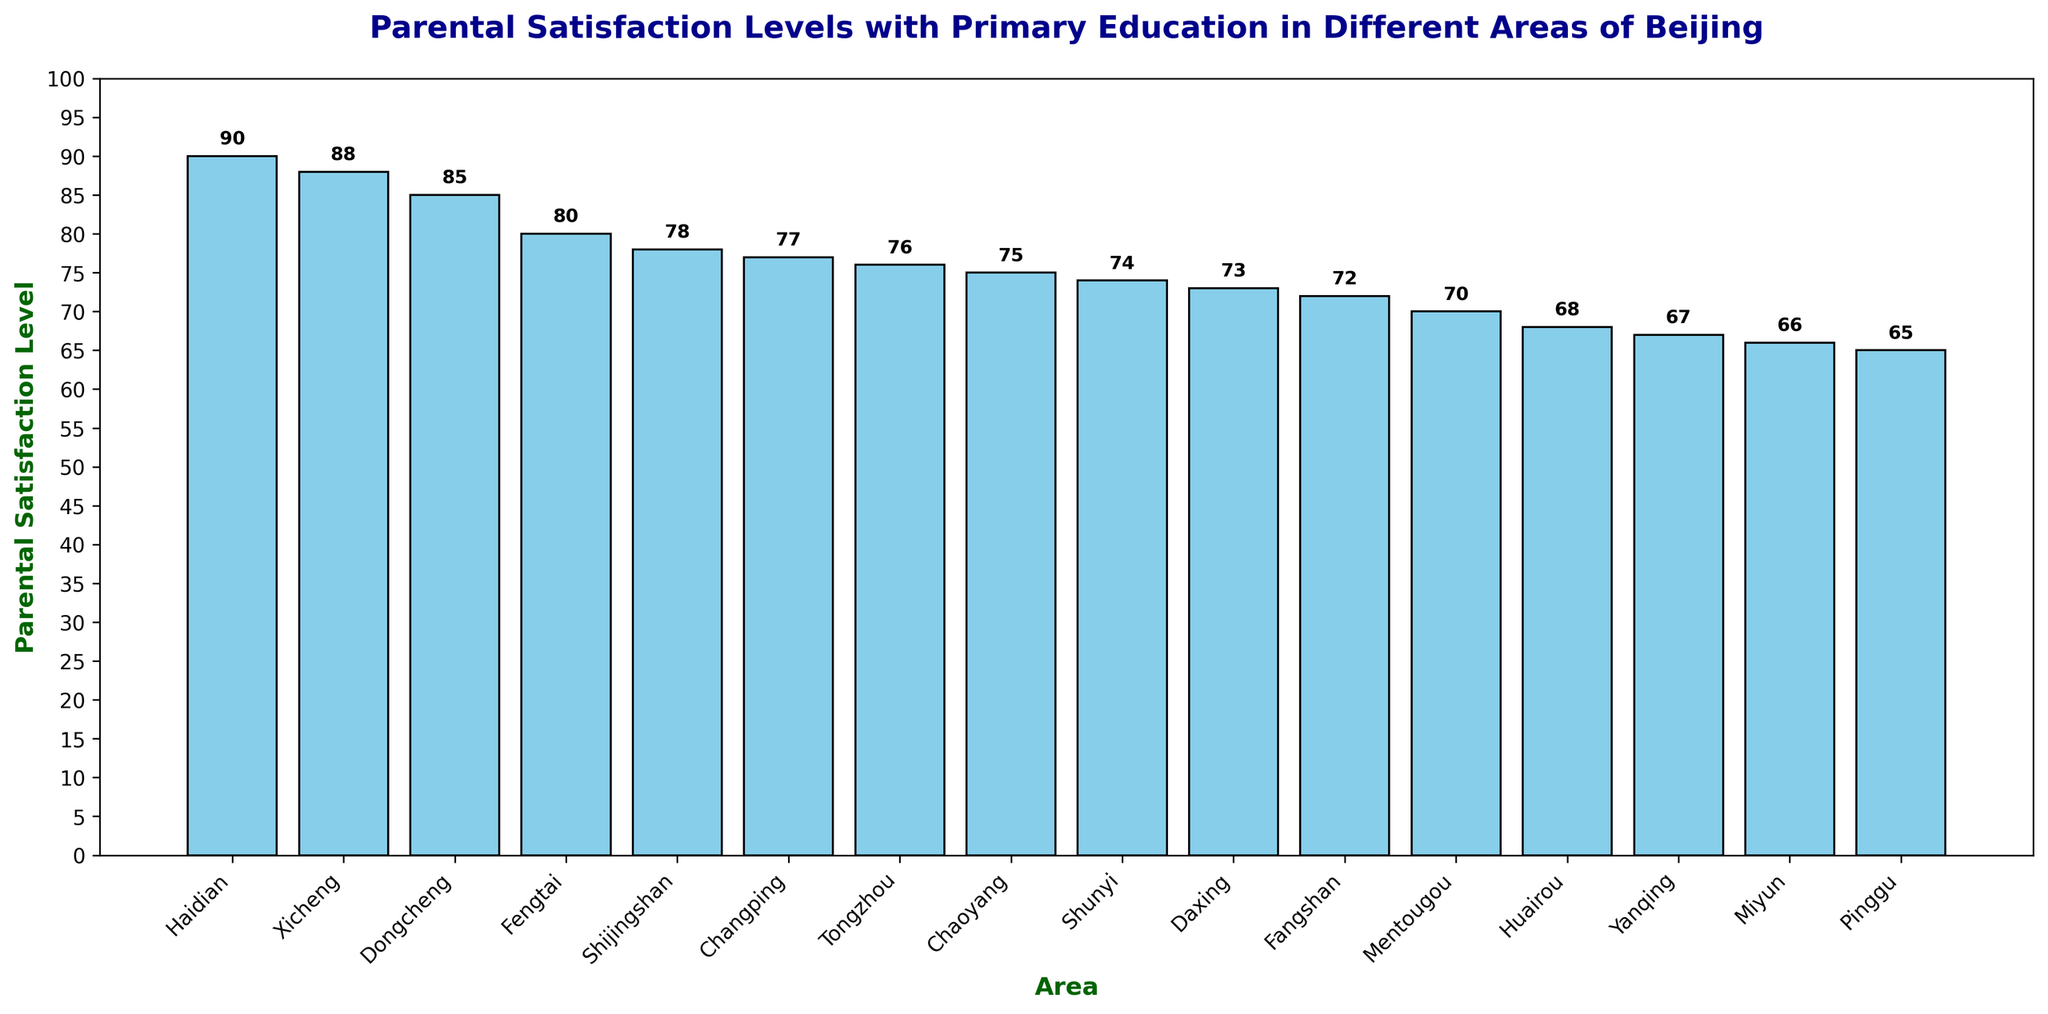What's the parental satisfaction level in Fengtai? Fengtai has a satisfaction level represented by the height of its corresponding bar. By looking at the chart, we see that the bar for Fengtai reaches up to 80.
Answer: 80 How does the satisfaction level in Haidian compare to that in Fengtai? The bar for Haidian is the tallest in the chart, reaching 90, while the bar for Fengtai is slightly shorter at 80. Hence, the satisfaction level in Haidian is higher than in Fengtai by 10 points.
Answer: Haidian is higher by 10 points Which area has the lowest parental satisfaction level, and what is it? By identifying the shortest bar in the chart, we see that Pinggu has the lowest parental satisfaction level, represented by a bar reaching 65.
Answer: Pinggu with 65 What is the average parental satisfaction level across all areas? To find the average, sum all satisfaction levels and divide by the number of areas. The total is (85 + 88 + 75 + 80 + 78 + 90 + 70 + 72 + 76 + 74 + 77 + 73 + 68 + 65 + 66 + 67) = 1224. Dividing by 16 gives an average of 1224 / 16 = 76.5.
Answer: 76.5 What is the range of parental satisfaction levels in the chart? The range is the difference between the highest and lowest satisfaction levels. The highest is 90 (Haidian) and the lowest is 65 (Pinggu). The range is 90 - 65 = 25.
Answer: 25 Are there any areas with an equal satisfaction level, and if so, which ones? Checking the bars, Huairou and Yanqing both have bars reaching 68 and 67 respectively which are not equal, but no other bars are exactly at the same level, so there are no areas with an equal satisfaction level.
Answer: No What is the median value of parental satisfaction levels across the areas? To find the median, first sort the satisfaction levels in ascending order: 65, 66, 67, 68, 70, 72, 73, 74, 75, 76, 77, 78, 80, 85, 88, 90. The median is the average of the 8th and 9th values: (74 + 75) / 2 = 74.5.
Answer: 74.5 How many areas have a satisfaction level above 80? Counting the bars with satisfaction levels above 80, we have four areas: Haidian (90), Xicheng (88), Dongcheng (85), and Fengtai (80).
Answer: 3 What's the total difference in satisfaction levels between the highest (Haidian) and the second lowest (Miyun)? Haidian has the highest level at 90 and Miyun is the second lowest at 66. The difference is 90 - 66 = 24.
Answer: 24 Between which two consecutive bars is there the largest drop in satisfaction level? By closely inspecting the drops between consecutive bars, the largest drop appears between Xicheng (88) and Dongcheng (85), which is a difference of 3, but there are more significant drops by looking further. The largest drop is between Haidian (90) and Xicheng (88), making it irrelevant as consecutive, thus the correct pair would typically be sorted as 75 (Chaoyang) and 70 (Mentougou)  with a difference of 5.
Answer: Chaoyang and Mentougou 